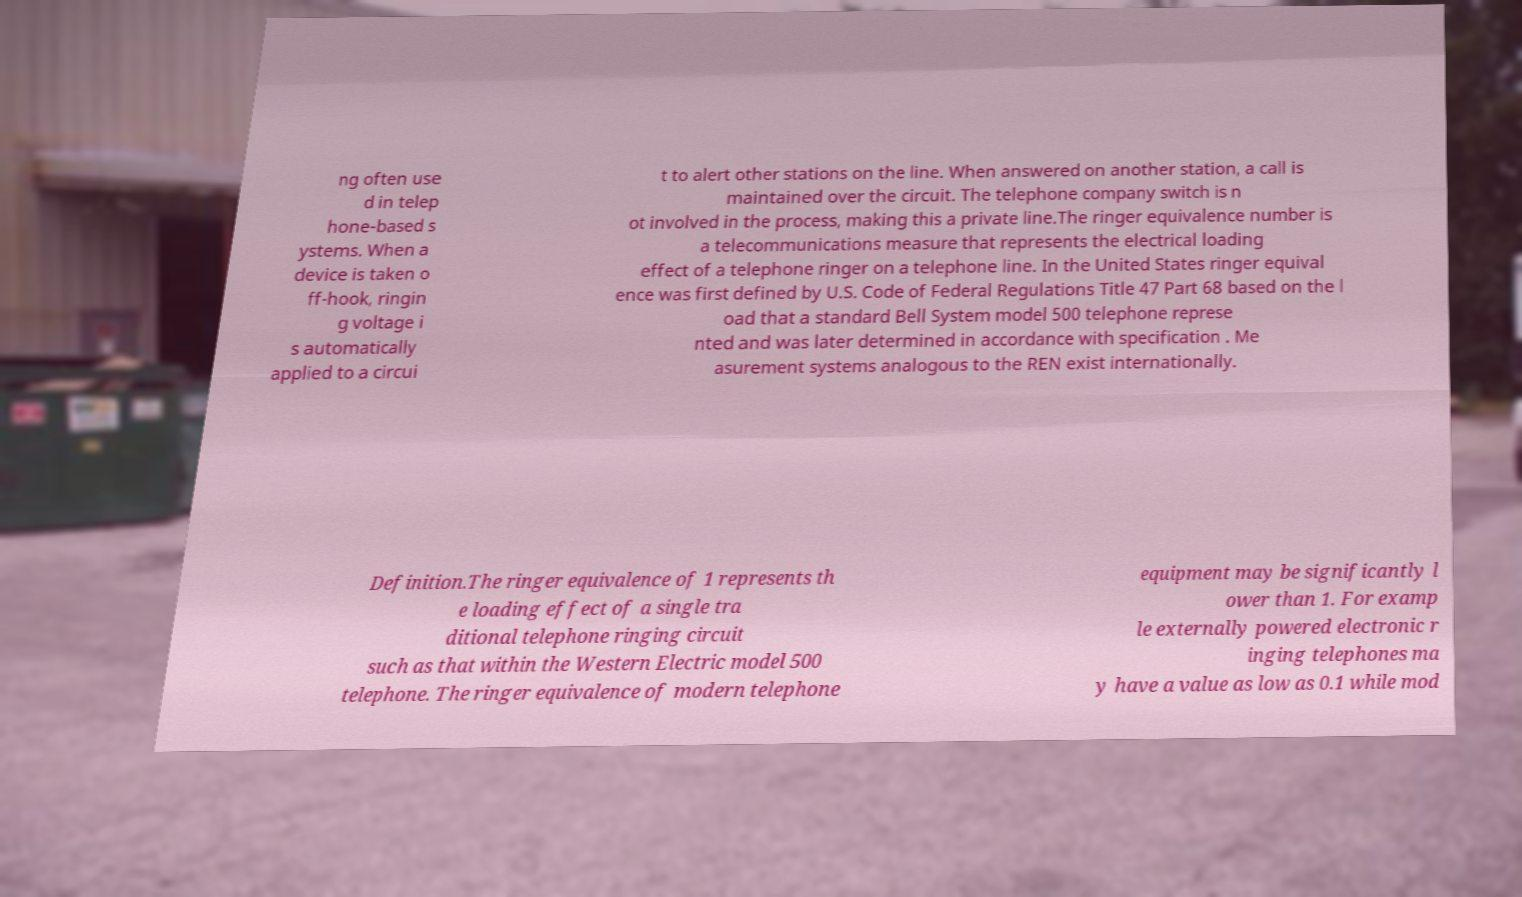Could you extract and type out the text from this image? ng often use d in telep hone-based s ystems. When a device is taken o ff-hook, ringin g voltage i s automatically applied to a circui t to alert other stations on the line. When answered on another station, a call is maintained over the circuit. The telephone company switch is n ot involved in the process, making this a private line.The ringer equivalence number is a telecommunications measure that represents the electrical loading effect of a telephone ringer on a telephone line. In the United States ringer equival ence was first defined by U.S. Code of Federal Regulations Title 47 Part 68 based on the l oad that a standard Bell System model 500 telephone represe nted and was later determined in accordance with specification . Me asurement systems analogous to the REN exist internationally. Definition.The ringer equivalence of 1 represents th e loading effect of a single tra ditional telephone ringing circuit such as that within the Western Electric model 500 telephone. The ringer equivalence of modern telephone equipment may be significantly l ower than 1. For examp le externally powered electronic r inging telephones ma y have a value as low as 0.1 while mod 